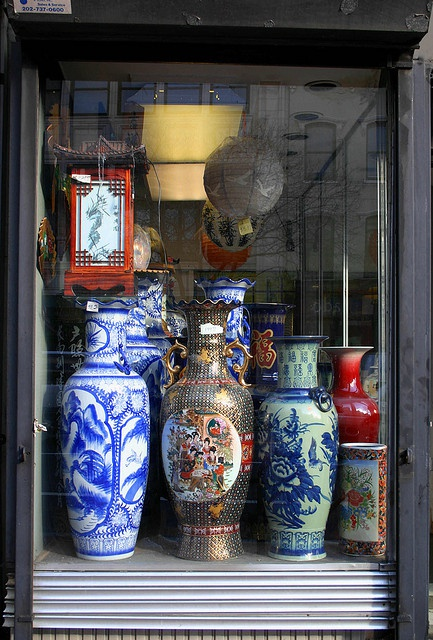Describe the objects in this image and their specific colors. I can see vase in black, gray, darkgray, and ivory tones, vase in black, white, lightblue, and blue tones, vase in black, navy, darkgray, and gray tones, vase in black, gray, darkgray, and maroon tones, and vase in black, navy, lightgray, and gray tones in this image. 